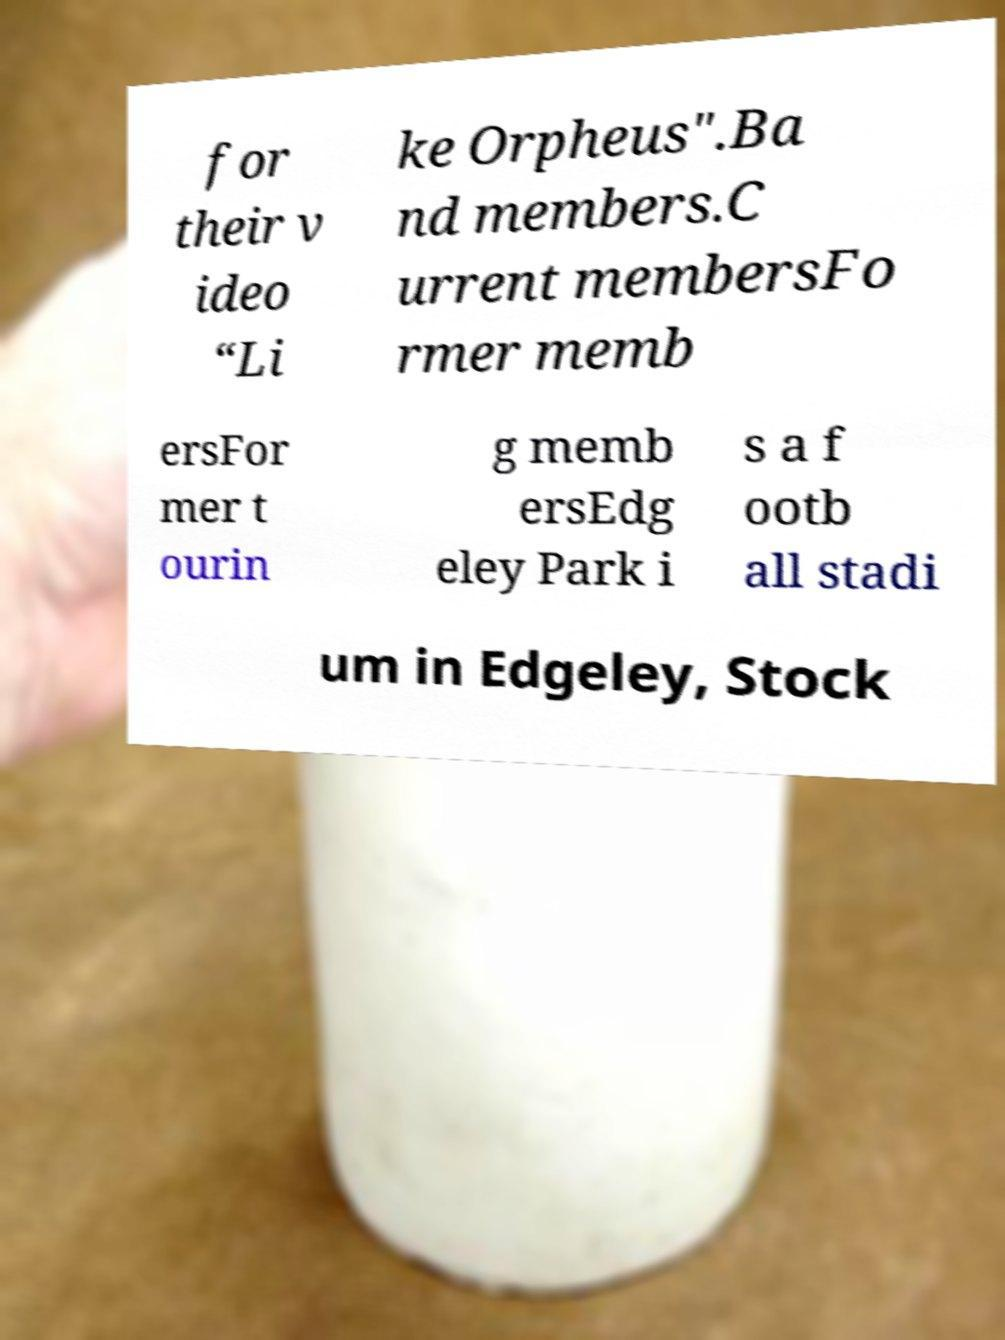Please read and relay the text visible in this image. What does it say? for their v ideo “Li ke Orpheus".Ba nd members.C urrent membersFo rmer memb ersFor mer t ourin g memb ersEdg eley Park i s a f ootb all stadi um in Edgeley, Stock 